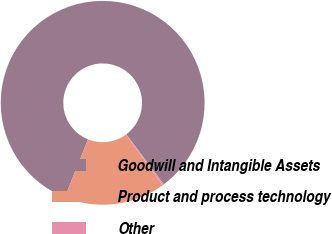Convert chart to OTSL. <chart><loc_0><loc_0><loc_500><loc_500><pie_chart><fcel>Goodwill and Intangible Assets<fcel>Product and process technology<fcel>Other<nl><fcel>83.72%<fcel>16.08%<fcel>0.21%<nl></chart> 